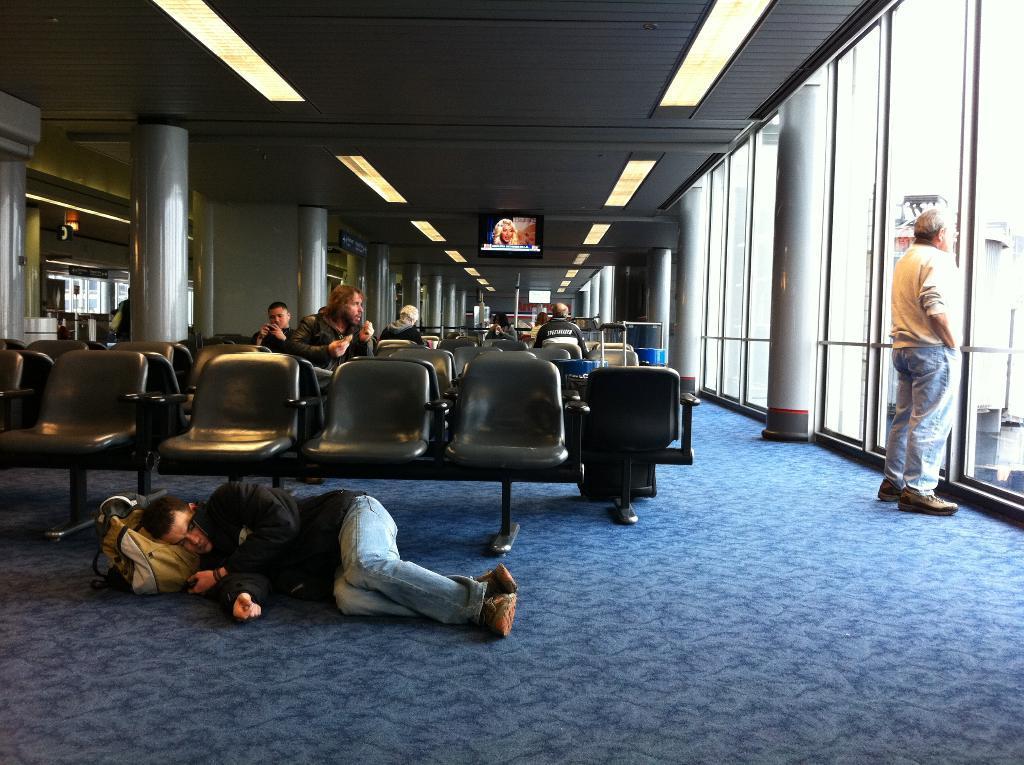Can you describe this image briefly? In this image i can see few people sitting on chairs and a person lying on the floor, to the right corner i can see another person standing, In the background i can see a television screen, the roof and lights to the roof. 